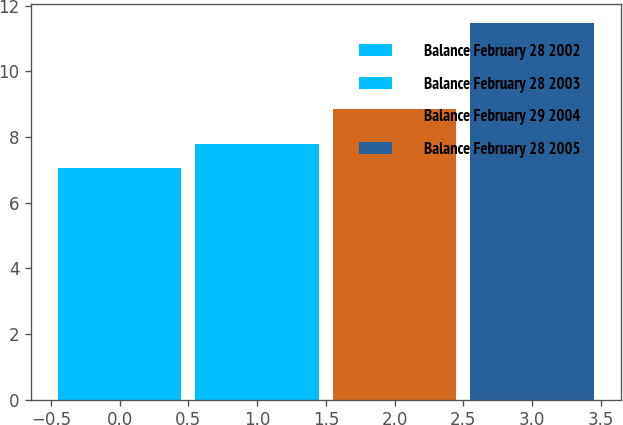<chart> <loc_0><loc_0><loc_500><loc_500><bar_chart><fcel>Balance February 28 2002<fcel>Balance February 28 2003<fcel>Balance February 29 2004<fcel>Balance February 28 2005<nl><fcel>7.06<fcel>7.78<fcel>8.86<fcel>11.48<nl></chart> 